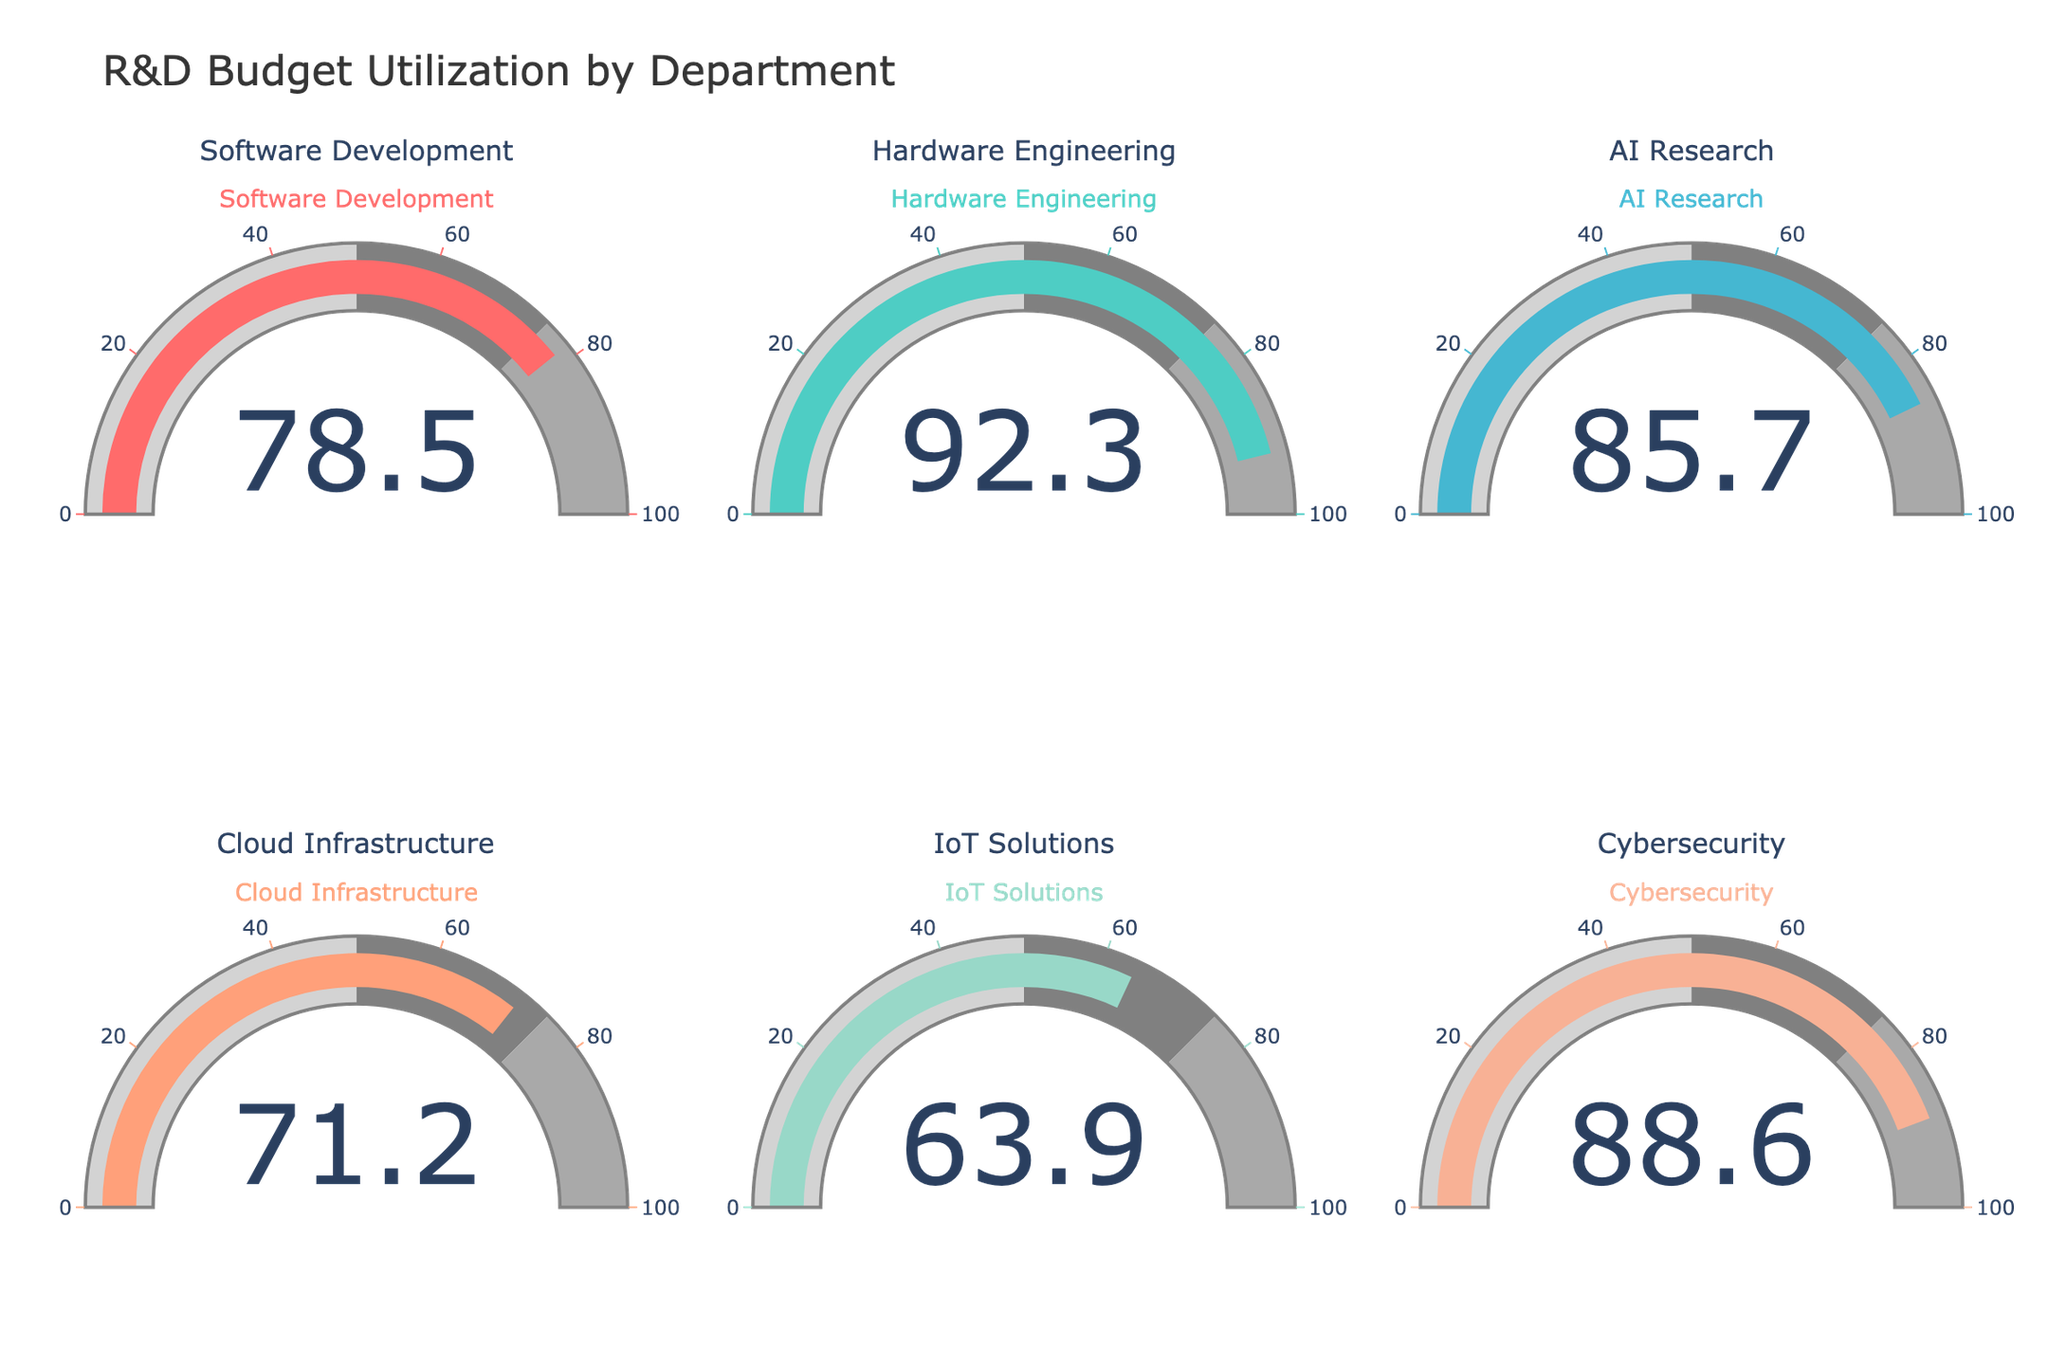What's the percentage of the R&D budget utilized by the Cybersecurity department? The gauge chart for the Cybersecurity department shows the value inside the gauge which represents the percentage utilized.
Answer: 88.6 What's the average percentage of the R&D budget utilized across all departments? To find the average, sum the percentages of all departments and divide by the number of departments: (78.5 + 92.3 + 85.7 + 71.2 + 63.9 + 88.6) / 6.
Answer: 80.03 Which department has utilized the least percentage of its R&D budget? Among the displayed values, the department with the smallest percentage is identified by comparing all the values.
Answer: IoT Solutions How much more percentage of the R&D budget has Hardware Engineering utilized compared to Cloud Infrastructure? Subtract the percentage of Cloud Infrastructure from that of Hardware Engineering: 92.3 - 71.2.
Answer: 21.1 Which department has the highest percentage of R&D budget utilization? Compare the percentages of all the departments and identify the highest one.
Answer: Hardware Engineering Are there any departments that have utilized more than 85% of their R&D budget? If so, list them. Check each department’s percentage and list those above 85%.
Answer: Hardware Engineering, AI Research, Cybersecurity What's the difference in budget utilization percentage between Software Development and AI Research departments? Subtract the percentage of Software Development from that of AI Research: 85.7 - 78.5.
Answer: 7.2 If the average budget utilization is required to be 75%, how many departments are above this average? Count the departments with percentages greater than 75%.
Answer: 4 What is the total percentage of the R&D budget utilized across Software Development and IoT Solutions departments? Sum the percentages of the two departments: 78.5 + 63.9.
Answer: 142.4 Which departments have utilized between 70% and 90% of their R&D budget? Identify the departments whose percentages fall within the range [70%, 90%].
Answer: Software Development, AI Research, Cloud Infrastructure, Cybersecurity 